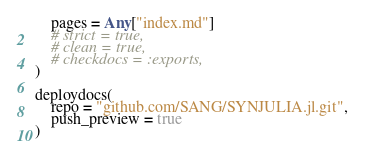<code> <loc_0><loc_0><loc_500><loc_500><_Julia_>    pages = Any["index.md"]
    # strict = true,
    # clean = true,
    # checkdocs = :exports,
)

deploydocs(
    repo = "github.com/SANG/SYNJULIA.jl.git",
    push_preview = true
)
</code> 